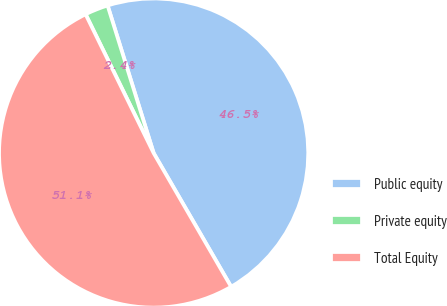Convert chart. <chart><loc_0><loc_0><loc_500><loc_500><pie_chart><fcel>Public equity<fcel>Private equity<fcel>Total Equity<nl><fcel>46.45%<fcel>2.44%<fcel>51.1%<nl></chart> 